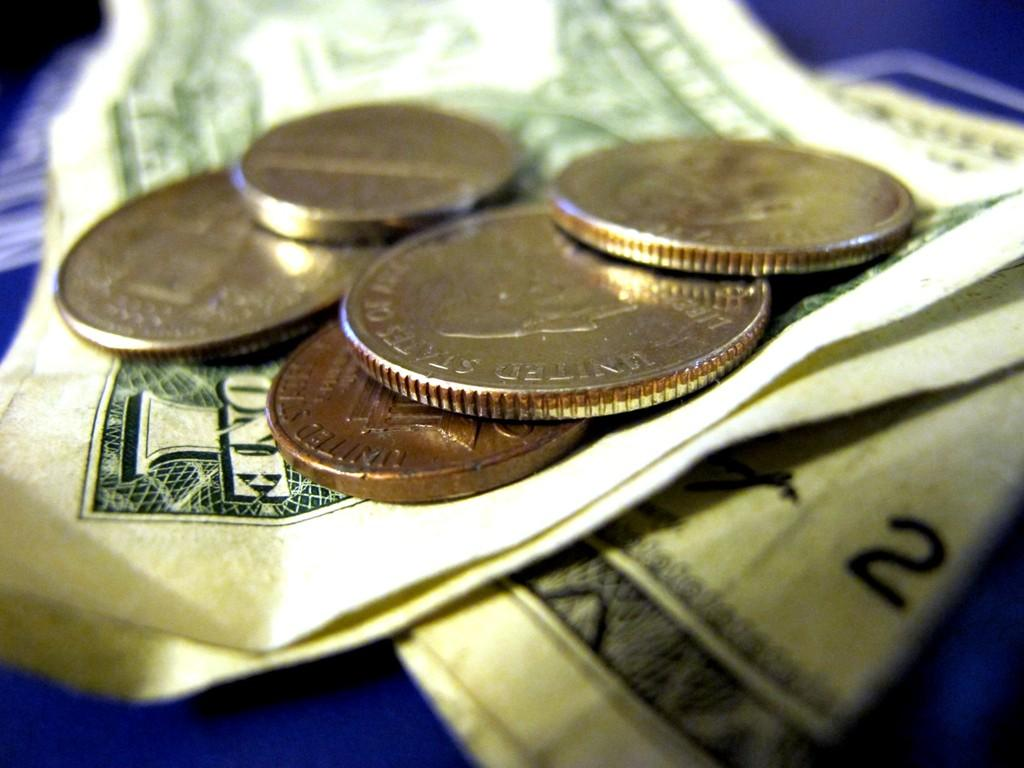<image>
Relay a brief, clear account of the picture shown. A closeup of  some coins and a paper bill with the word "one" on it 